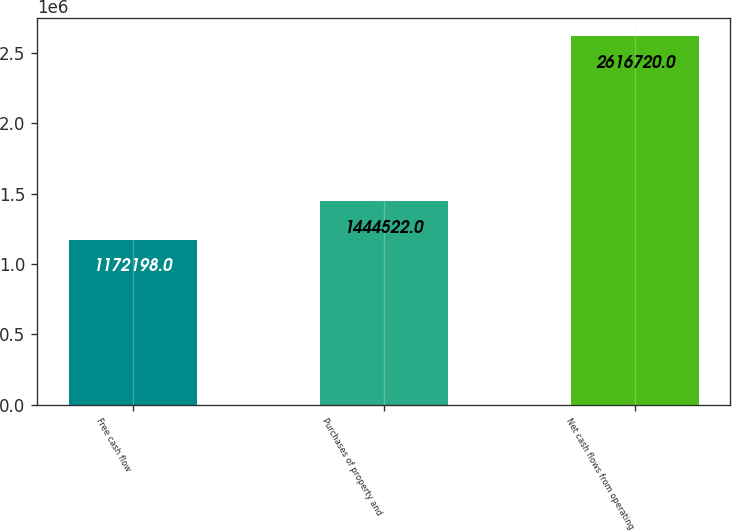<chart> <loc_0><loc_0><loc_500><loc_500><bar_chart><fcel>Free cash flow<fcel>Purchases of property and<fcel>Net cash flows from operating<nl><fcel>1.1722e+06<fcel>1.44452e+06<fcel>2.61672e+06<nl></chart> 